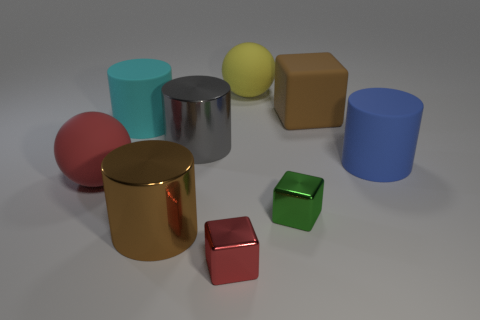Subtract all gray cylinders. How many cylinders are left? 3 Subtract all red blocks. How many blocks are left? 2 Subtract all balls. How many objects are left? 7 Subtract 3 cylinders. How many cylinders are left? 1 Add 3 big yellow balls. How many big yellow balls are left? 4 Add 4 large brown things. How many large brown things exist? 6 Subtract 0 blue balls. How many objects are left? 9 Subtract all cyan cubes. Subtract all cyan balls. How many cubes are left? 3 Subtract all blue spheres. How many gray cylinders are left? 1 Subtract all large red rubber things. Subtract all large blue matte objects. How many objects are left? 7 